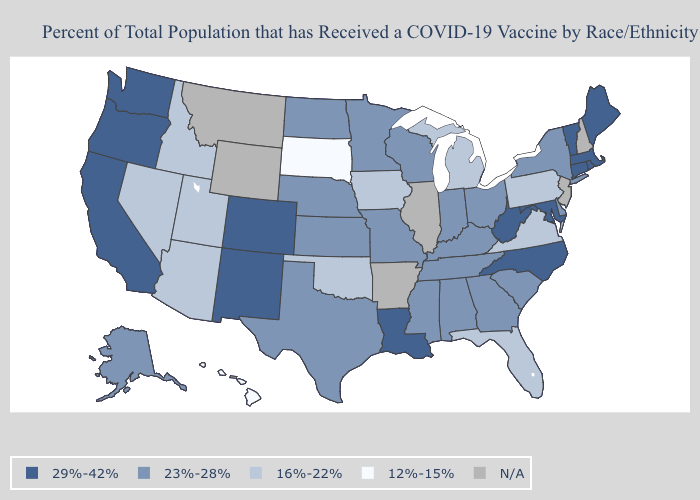What is the value of Wyoming?
Give a very brief answer. N/A. What is the lowest value in the South?
Concise answer only. 16%-22%. What is the highest value in states that border Tennessee?
Keep it brief. 29%-42%. Which states have the lowest value in the MidWest?
Short answer required. South Dakota. What is the value of North Dakota?
Give a very brief answer. 23%-28%. Name the states that have a value in the range 12%-15%?
Be succinct. Hawaii, South Dakota. What is the lowest value in the USA?
Concise answer only. 12%-15%. What is the value of Idaho?
Concise answer only. 16%-22%. Does Utah have the highest value in the West?
Concise answer only. No. Does Nevada have the highest value in the West?
Concise answer only. No. Does Pennsylvania have the lowest value in the Northeast?
Quick response, please. Yes. Which states hav the highest value in the Northeast?
Answer briefly. Connecticut, Maine, Massachusetts, Rhode Island, Vermont. Does the first symbol in the legend represent the smallest category?
Write a very short answer. No. 